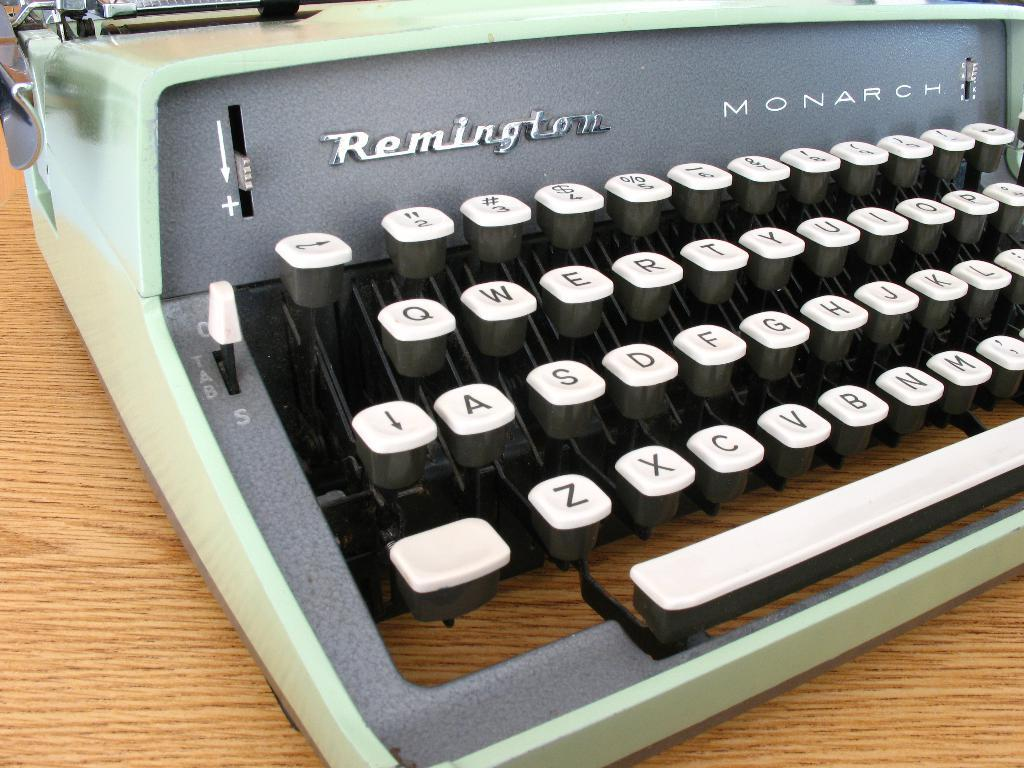<image>
Summarize the visual content of the image. a typewriter a typewriter with the word Remington on it 